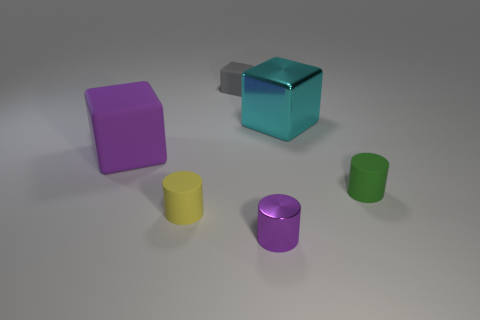Subtract all yellow cylinders. How many cylinders are left? 2 Subtract 3 cubes. How many cubes are left? 0 Subtract all green cylinders. How many cylinders are left? 2 Subtract all gray blocks. Subtract all red spheres. How many blocks are left? 2 Subtract all yellow blocks. How many cyan cylinders are left? 0 Subtract all gray things. Subtract all big blocks. How many objects are left? 3 Add 1 small green rubber cylinders. How many small green rubber cylinders are left? 2 Add 6 metallic spheres. How many metallic spheres exist? 6 Add 4 tiny things. How many objects exist? 10 Subtract 0 blue spheres. How many objects are left? 6 